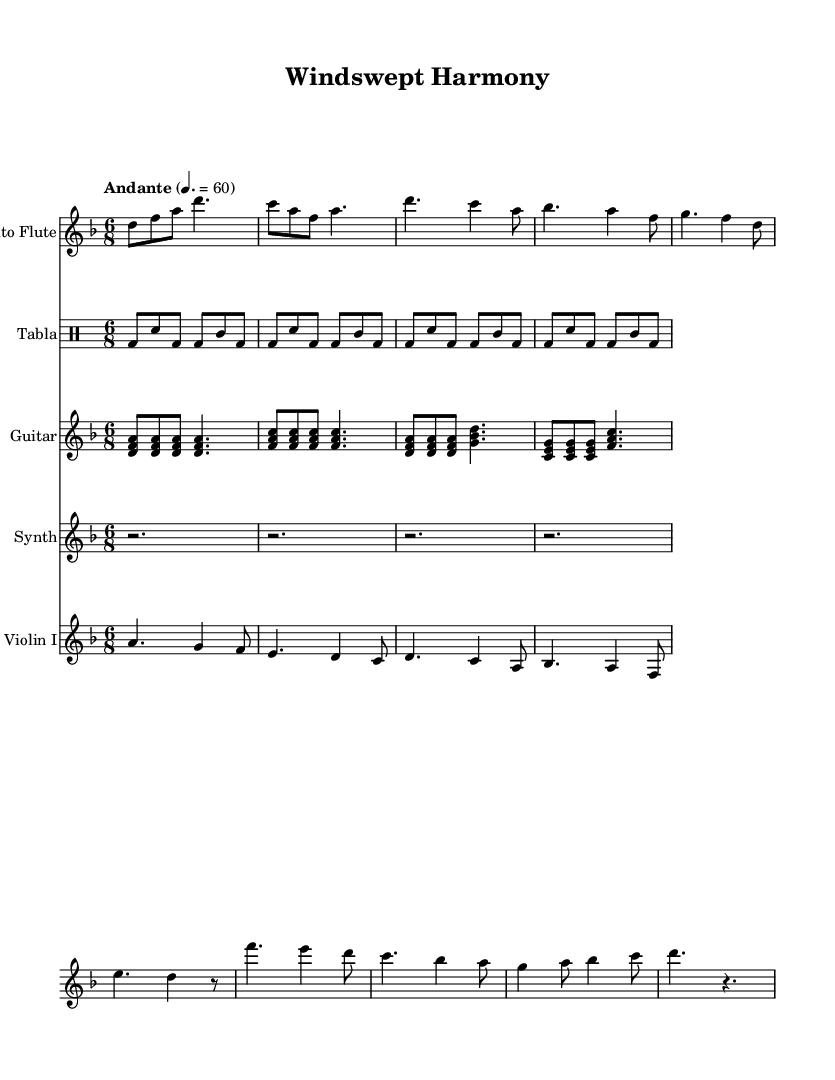What is the key signature of this music? The key signature is indicated at the beginning of the staff. The presence of one flat indicates that the key is D minor.
Answer: D minor What is the time signature of this music? The time signature can be found right after the key signature, displayed as 6/8. This indicates there are six beats in each measure, with the eighth note receiving the beat.
Answer: 6/8 What is the tempo marking of the piece? The tempo marking is shown above the staff, stating "Andante" and a metronome marking of 60, suggesting a moderately slow pace.
Answer: Andante 60 How many instruments are featured in this score? By counting the different staves presented in the score, there are a total of five distinct instruments: Alto Flute, Tabla, Guitar, Synth, and Violin I.
Answer: Five What rhythmic pattern is played by the Tabla? The rhythmic pattern can be discerned by examining the drum notation, which shows a repeated motif consisting of bass drum and snare hits. The pattern features a combination of bass and snare beats.
Answer: Bass-Dominate Pattern Is there a synthesizer part included, and if so, what does it consist of? The synthesizer part appears in the score, indicated by the labeled staff. Upon examining its contents, it is silent for the entire duration of the piece, consisting only of rests.
Answer: Yes, rests 